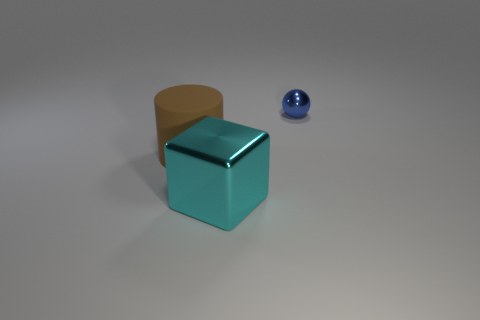There is a small thing on the right side of the cyan shiny cube; are there any big metallic things that are in front of it?
Provide a succinct answer. Yes. How many other metallic cubes have the same size as the cyan metallic block?
Keep it short and to the point. 0. How many metallic balls are on the right side of the blue object behind the shiny thing in front of the shiny ball?
Offer a terse response. 0. What number of things are both on the left side of the tiny blue shiny thing and on the right side of the big rubber thing?
Your answer should be compact. 1. Is there any other thing of the same color as the cylinder?
Provide a short and direct response. No. What number of metal objects are either cylinders or tiny things?
Your answer should be very brief. 1. What material is the object in front of the big thing that is behind the object in front of the brown object made of?
Your response must be concise. Metal. What material is the large object that is on the left side of the metallic object on the left side of the small blue object?
Keep it short and to the point. Rubber. Does the thing that is to the right of the cyan object have the same size as the thing on the left side of the big cyan thing?
Your answer should be very brief. No. Are there any other things that are the same material as the brown thing?
Offer a very short reply. No. 